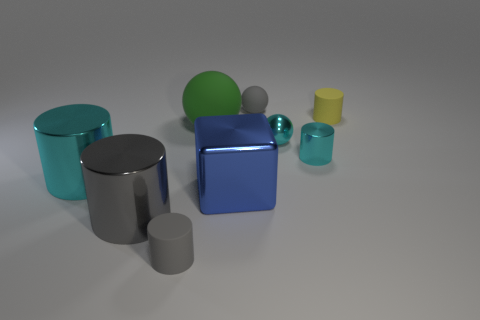Subtract all yellow cylinders. How many cylinders are left? 4 Subtract all yellow cylinders. How many cylinders are left? 4 Subtract all gray balls. Subtract all green blocks. How many balls are left? 2 Add 1 metal cubes. How many objects exist? 10 Subtract all balls. How many objects are left? 6 Subtract all small shiny cylinders. Subtract all gray objects. How many objects are left? 5 Add 2 tiny matte cylinders. How many tiny matte cylinders are left? 4 Add 4 balls. How many balls exist? 7 Subtract 0 gray cubes. How many objects are left? 9 